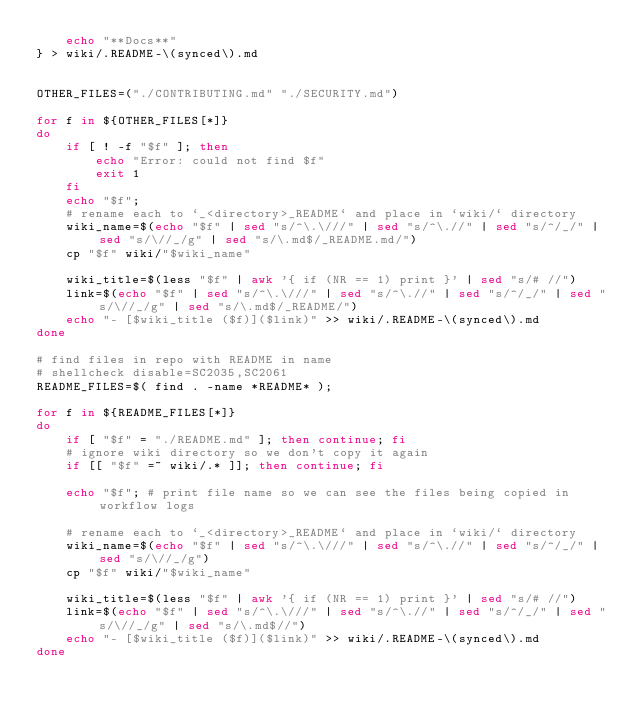Convert code to text. <code><loc_0><loc_0><loc_500><loc_500><_Bash_>    echo "**Docs**"
} > wiki/.README-\(synced\).md


OTHER_FILES=("./CONTRIBUTING.md" "./SECURITY.md")

for f in ${OTHER_FILES[*]}
do
    if [ ! -f "$f" ]; then
        echo "Error: could not find $f"
        exit 1
    fi
    echo "$f";
    # rename each to `_<directory>_README` and place in `wiki/` directory 
    wiki_name=$(echo "$f" | sed "s/^\.\///" | sed "s/^\.//" | sed "s/^/_/" | sed "s/\//_/g" | sed "s/\.md$/_README.md/")
    cp "$f" wiki/"$wiki_name"

    wiki_title=$(less "$f" | awk '{ if (NR == 1) print }' | sed "s/# //") 
    link=$(echo "$f" | sed "s/^\.\///" | sed "s/^\.//" | sed "s/^/_/" | sed "s/\//_/g" | sed "s/\.md$/_README/")
    echo "- [$wiki_title ($f)]($link)" >> wiki/.README-\(synced\).md
done

# find files in repo with README in name
# shellcheck disable=SC2035,SC2061
README_FILES=$( find . -name *README* );

for f in ${README_FILES[*]}
do
    if [ "$f" = "./README.md" ]; then continue; fi
    # ignore wiki directory so we don't copy it again
    if [[ "$f" =~ wiki/.* ]]; then continue; fi
    
    echo "$f"; # print file name so we can see the files being copied in workflow logs

    # rename each to `_<directory>_README` and place in `wiki/` directory 
    wiki_name=$(echo "$f" | sed "s/^\.\///" | sed "s/^\.//" | sed "s/^/_/" | sed "s/\//_/g")
    cp "$f" wiki/"$wiki_name"

    wiki_title=$(less "$f" | awk '{ if (NR == 1) print }' | sed "s/# //") 
    link=$(echo "$f" | sed "s/^\.\///" | sed "s/^\.//" | sed "s/^/_/" | sed "s/\//_/g" | sed "s/\.md$//")
    echo "- [$wiki_title ($f)]($link)" >> wiki/.README-\(synced\).md
done
</code> 